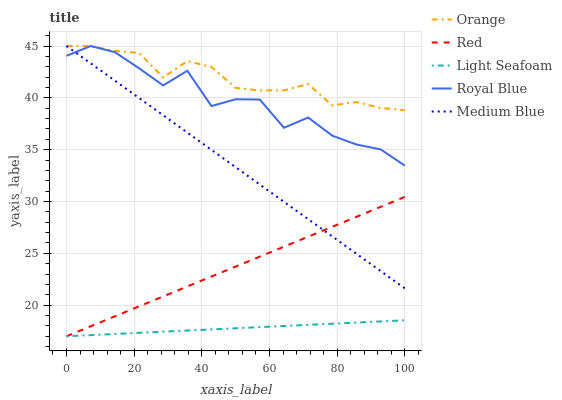Does Light Seafoam have the minimum area under the curve?
Answer yes or no. Yes. Does Orange have the maximum area under the curve?
Answer yes or no. Yes. Does Royal Blue have the minimum area under the curve?
Answer yes or no. No. Does Royal Blue have the maximum area under the curve?
Answer yes or no. No. Is Light Seafoam the smoothest?
Answer yes or no. Yes. Is Royal Blue the roughest?
Answer yes or no. Yes. Is Royal Blue the smoothest?
Answer yes or no. No. Is Light Seafoam the roughest?
Answer yes or no. No. Does Light Seafoam have the lowest value?
Answer yes or no. Yes. Does Royal Blue have the lowest value?
Answer yes or no. No. Does Medium Blue have the highest value?
Answer yes or no. Yes. Does Light Seafoam have the highest value?
Answer yes or no. No. Is Light Seafoam less than Orange?
Answer yes or no. Yes. Is Royal Blue greater than Red?
Answer yes or no. Yes. Does Royal Blue intersect Orange?
Answer yes or no. Yes. Is Royal Blue less than Orange?
Answer yes or no. No. Is Royal Blue greater than Orange?
Answer yes or no. No. Does Light Seafoam intersect Orange?
Answer yes or no. No. 